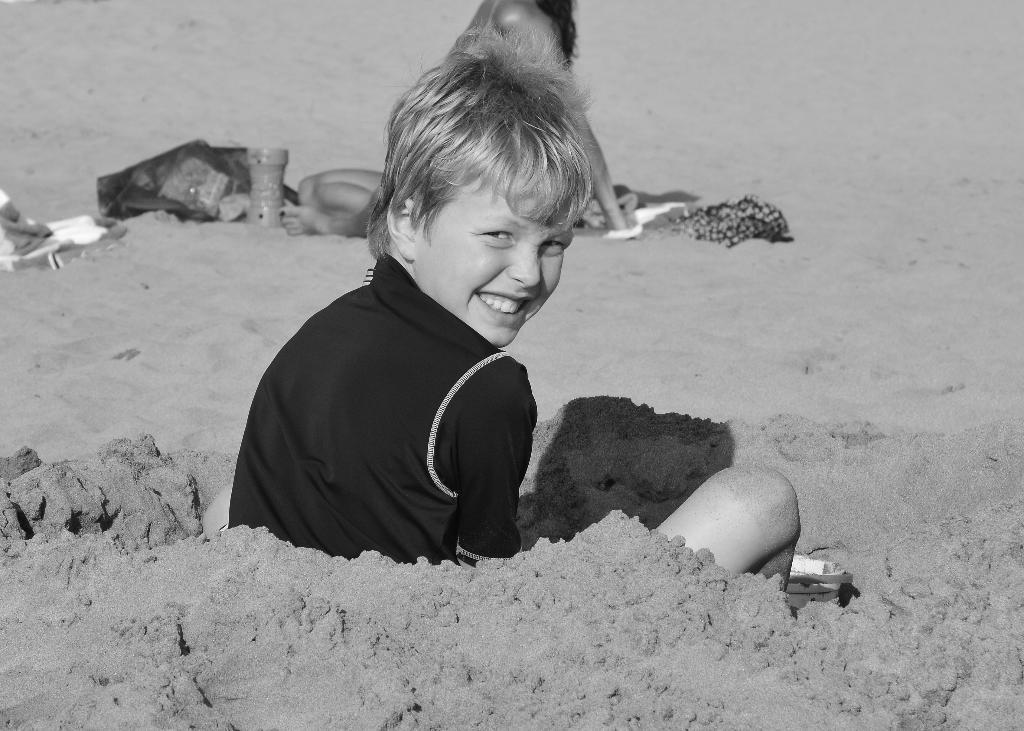What is the main subject of the image? There is a child in the image. What is the child doing in the image? The child is sitting on sand and smiling. Can you describe the background of the image? There is a woman, clothes, and objects visible in the background of the image. What type of leaf is the child holding in the image? There is no leaf present in the image; the child is sitting on sand and smiling. How many tickets can be seen in the image? There are no tickets present in the image. 